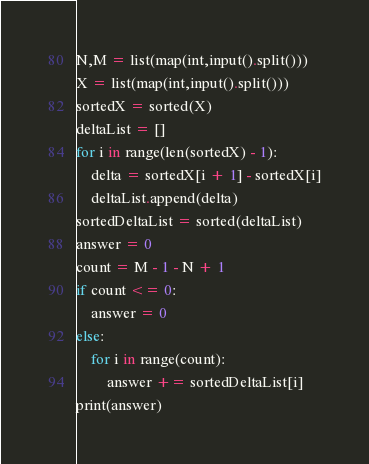<code> <loc_0><loc_0><loc_500><loc_500><_Python_>N,M = list(map(int,input().split()))
X = list(map(int,input().split()))
sortedX = sorted(X)
deltaList = []
for i in range(len(sortedX) - 1):
    delta = sortedX[i + 1] - sortedX[i]
    deltaList.append(delta)
sortedDeltaList = sorted(deltaList)
answer = 0
count = M - 1 - N + 1
if count <= 0:
    answer = 0
else:
    for i in range(count):
        answer += sortedDeltaList[i]
print(answer)</code> 